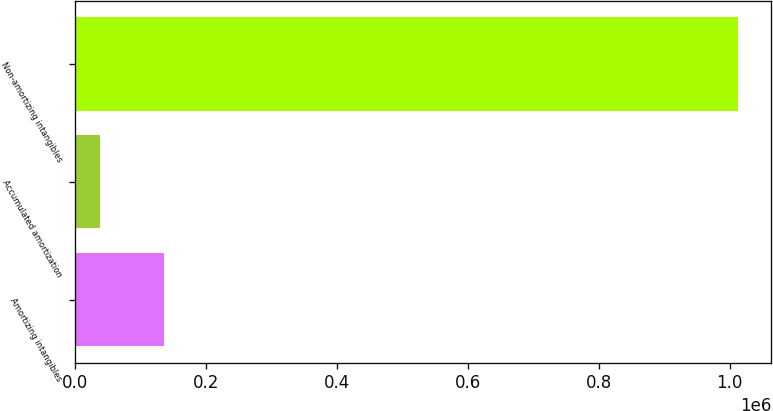Convert chart. <chart><loc_0><loc_0><loc_500><loc_500><bar_chart><fcel>Amortizing intangibles<fcel>Accumulated amortization<fcel>Non-amortizing intangibles<nl><fcel>135764<fcel>38311<fcel>1.01284e+06<nl></chart> 